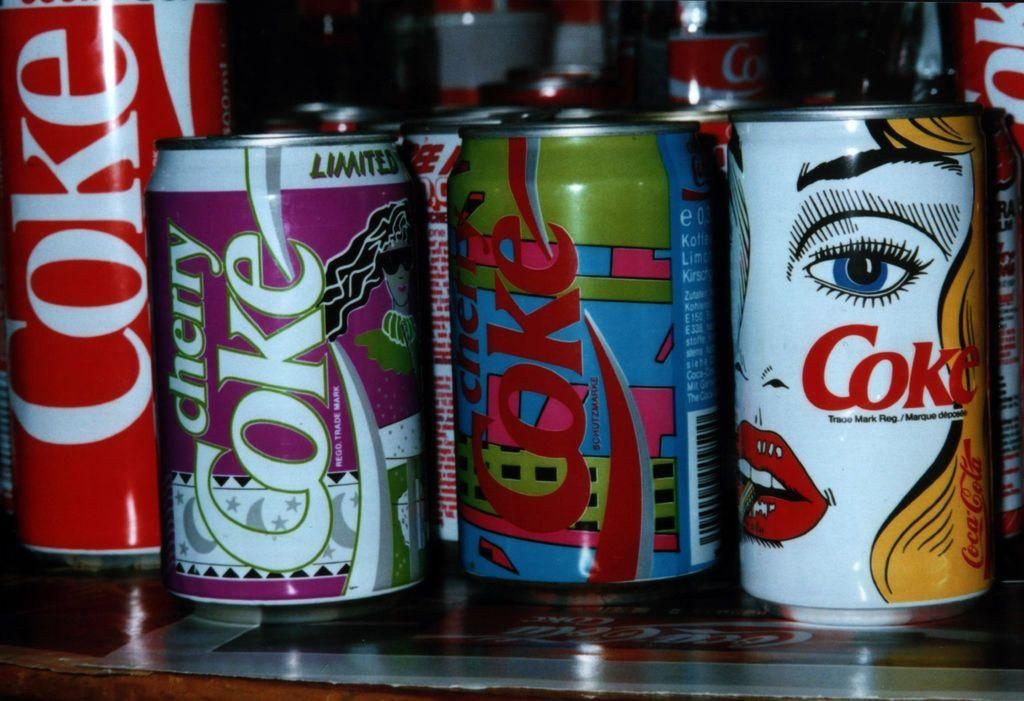<image>
Summarize the visual content of the image. An assortment of Coke cans with different designs sit next to each other. 